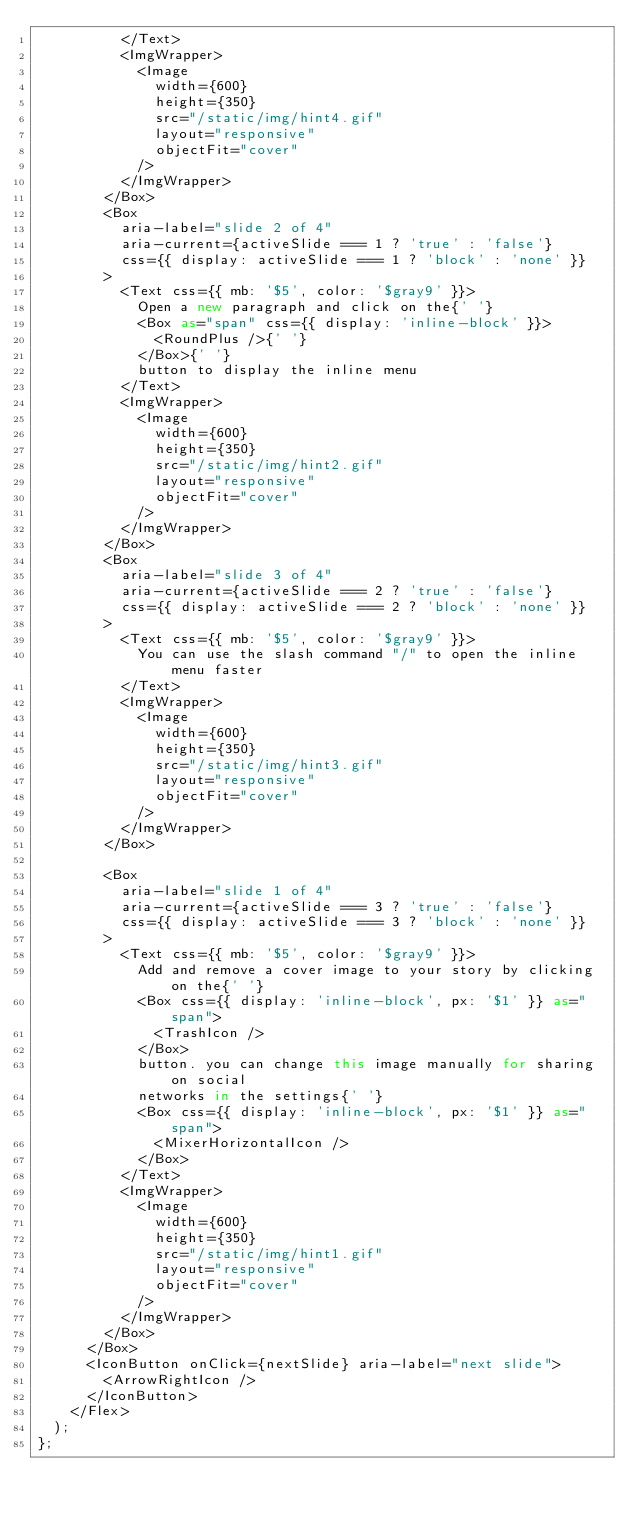<code> <loc_0><loc_0><loc_500><loc_500><_TypeScript_>          </Text>
          <ImgWrapper>
            <Image
              width={600}
              height={350}
              src="/static/img/hint4.gif"
              layout="responsive"
              objectFit="cover"
            />
          </ImgWrapper>
        </Box>
        <Box
          aria-label="slide 2 of 4"
          aria-current={activeSlide === 1 ? 'true' : 'false'}
          css={{ display: activeSlide === 1 ? 'block' : 'none' }}
        >
          <Text css={{ mb: '$5', color: '$gray9' }}>
            Open a new paragraph and click on the{' '}
            <Box as="span" css={{ display: 'inline-block' }}>
              <RoundPlus />{' '}
            </Box>{' '}
            button to display the inline menu
          </Text>
          <ImgWrapper>
            <Image
              width={600}
              height={350}
              src="/static/img/hint2.gif"
              layout="responsive"
              objectFit="cover"
            />
          </ImgWrapper>
        </Box>
        <Box
          aria-label="slide 3 of 4"
          aria-current={activeSlide === 2 ? 'true' : 'false'}
          css={{ display: activeSlide === 2 ? 'block' : 'none' }}
        >
          <Text css={{ mb: '$5', color: '$gray9' }}>
            You can use the slash command "/" to open the inline menu faster
          </Text>
          <ImgWrapper>
            <Image
              width={600}
              height={350}
              src="/static/img/hint3.gif"
              layout="responsive"
              objectFit="cover"
            />
          </ImgWrapper>
        </Box>

        <Box
          aria-label="slide 1 of 4"
          aria-current={activeSlide === 3 ? 'true' : 'false'}
          css={{ display: activeSlide === 3 ? 'block' : 'none' }}
        >
          <Text css={{ mb: '$5', color: '$gray9' }}>
            Add and remove a cover image to your story by clicking on the{' '}
            <Box css={{ display: 'inline-block', px: '$1' }} as="span">
              <TrashIcon />
            </Box>
            button. you can change this image manually for sharing on social
            networks in the settings{' '}
            <Box css={{ display: 'inline-block', px: '$1' }} as="span">
              <MixerHorizontalIcon />
            </Box>
          </Text>
          <ImgWrapper>
            <Image
              width={600}
              height={350}
              src="/static/img/hint1.gif"
              layout="responsive"
              objectFit="cover"
            />
          </ImgWrapper>
        </Box>
      </Box>
      <IconButton onClick={nextSlide} aria-label="next slide">
        <ArrowRightIcon />
      </IconButton>
    </Flex>
  );
};
</code> 